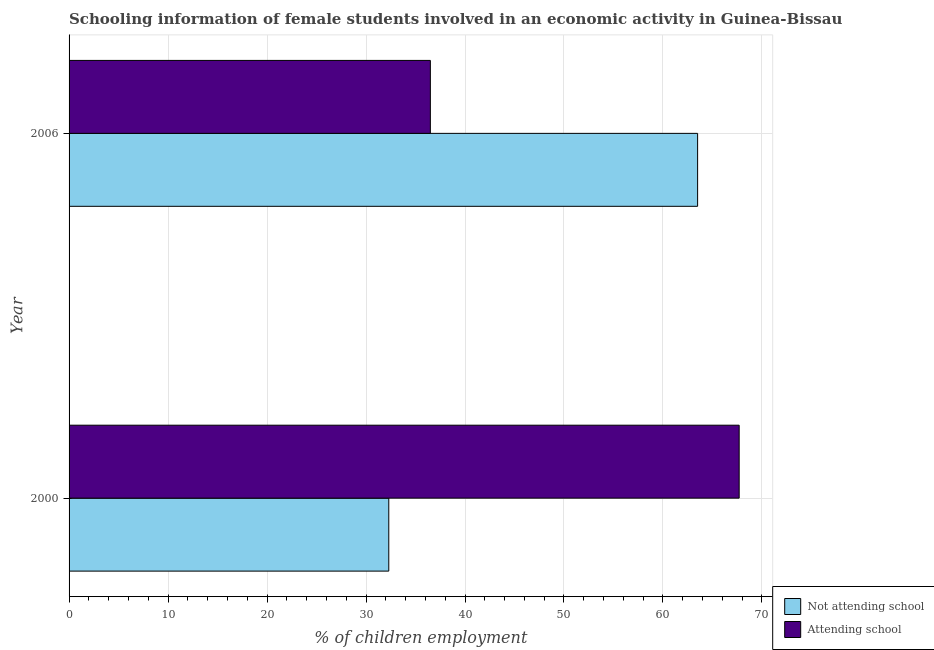How many groups of bars are there?
Offer a terse response. 2. Are the number of bars per tick equal to the number of legend labels?
Provide a short and direct response. Yes. What is the percentage of employed females who are not attending school in 2000?
Make the answer very short. 32.3. Across all years, what is the maximum percentage of employed females who are attending school?
Your answer should be very brief. 67.7. Across all years, what is the minimum percentage of employed females who are not attending school?
Keep it short and to the point. 32.3. In which year was the percentage of employed females who are attending school maximum?
Make the answer very short. 2000. What is the total percentage of employed females who are attending school in the graph?
Make the answer very short. 104.2. What is the difference between the percentage of employed females who are attending school in 2000 and that in 2006?
Offer a terse response. 31.2. What is the difference between the percentage of employed females who are not attending school in 2000 and the percentage of employed females who are attending school in 2006?
Your answer should be compact. -4.2. What is the average percentage of employed females who are attending school per year?
Keep it short and to the point. 52.1. In the year 2000, what is the difference between the percentage of employed females who are not attending school and percentage of employed females who are attending school?
Provide a short and direct response. -35.4. In how many years, is the percentage of employed females who are attending school greater than 60 %?
Provide a short and direct response. 1. What is the ratio of the percentage of employed females who are attending school in 2000 to that in 2006?
Ensure brevity in your answer.  1.85. Is the percentage of employed females who are attending school in 2000 less than that in 2006?
Your response must be concise. No. Is the difference between the percentage of employed females who are attending school in 2000 and 2006 greater than the difference between the percentage of employed females who are not attending school in 2000 and 2006?
Provide a succinct answer. Yes. In how many years, is the percentage of employed females who are attending school greater than the average percentage of employed females who are attending school taken over all years?
Ensure brevity in your answer.  1. What does the 2nd bar from the top in 2000 represents?
Provide a succinct answer. Not attending school. What does the 2nd bar from the bottom in 2006 represents?
Provide a succinct answer. Attending school. How many bars are there?
Provide a succinct answer. 4. Are all the bars in the graph horizontal?
Give a very brief answer. Yes. What is the difference between two consecutive major ticks on the X-axis?
Make the answer very short. 10. Does the graph contain any zero values?
Your response must be concise. No. Where does the legend appear in the graph?
Offer a very short reply. Bottom right. How are the legend labels stacked?
Your answer should be very brief. Vertical. What is the title of the graph?
Your response must be concise. Schooling information of female students involved in an economic activity in Guinea-Bissau. What is the label or title of the X-axis?
Your response must be concise. % of children employment. What is the label or title of the Y-axis?
Offer a very short reply. Year. What is the % of children employment in Not attending school in 2000?
Ensure brevity in your answer.  32.3. What is the % of children employment of Attending school in 2000?
Your response must be concise. 67.7. What is the % of children employment of Not attending school in 2006?
Ensure brevity in your answer.  63.5. What is the % of children employment in Attending school in 2006?
Your answer should be compact. 36.5. Across all years, what is the maximum % of children employment of Not attending school?
Your response must be concise. 63.5. Across all years, what is the maximum % of children employment in Attending school?
Give a very brief answer. 67.7. Across all years, what is the minimum % of children employment of Not attending school?
Your response must be concise. 32.3. Across all years, what is the minimum % of children employment in Attending school?
Keep it short and to the point. 36.5. What is the total % of children employment in Not attending school in the graph?
Provide a short and direct response. 95.8. What is the total % of children employment of Attending school in the graph?
Make the answer very short. 104.2. What is the difference between the % of children employment of Not attending school in 2000 and that in 2006?
Provide a succinct answer. -31.2. What is the difference between the % of children employment in Attending school in 2000 and that in 2006?
Provide a succinct answer. 31.2. What is the difference between the % of children employment in Not attending school in 2000 and the % of children employment in Attending school in 2006?
Offer a very short reply. -4.2. What is the average % of children employment in Not attending school per year?
Provide a succinct answer. 47.9. What is the average % of children employment of Attending school per year?
Offer a very short reply. 52.1. In the year 2000, what is the difference between the % of children employment in Not attending school and % of children employment in Attending school?
Give a very brief answer. -35.4. What is the ratio of the % of children employment in Not attending school in 2000 to that in 2006?
Your response must be concise. 0.51. What is the ratio of the % of children employment of Attending school in 2000 to that in 2006?
Give a very brief answer. 1.85. What is the difference between the highest and the second highest % of children employment of Not attending school?
Give a very brief answer. 31.2. What is the difference between the highest and the second highest % of children employment of Attending school?
Your answer should be compact. 31.2. What is the difference between the highest and the lowest % of children employment of Not attending school?
Make the answer very short. 31.2. What is the difference between the highest and the lowest % of children employment in Attending school?
Make the answer very short. 31.2. 